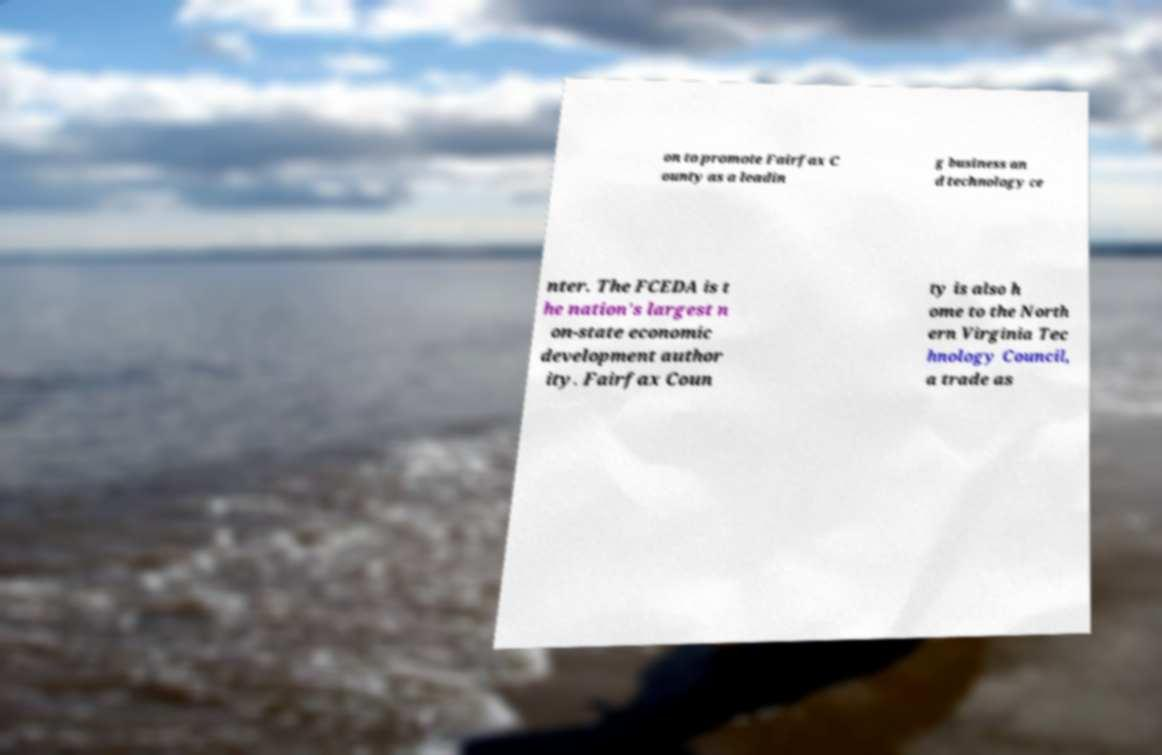Can you read and provide the text displayed in the image?This photo seems to have some interesting text. Can you extract and type it out for me? on to promote Fairfax C ounty as a leadin g business an d technology ce nter. The FCEDA is t he nation's largest n on-state economic development author ity. Fairfax Coun ty is also h ome to the North ern Virginia Tec hnology Council, a trade as 